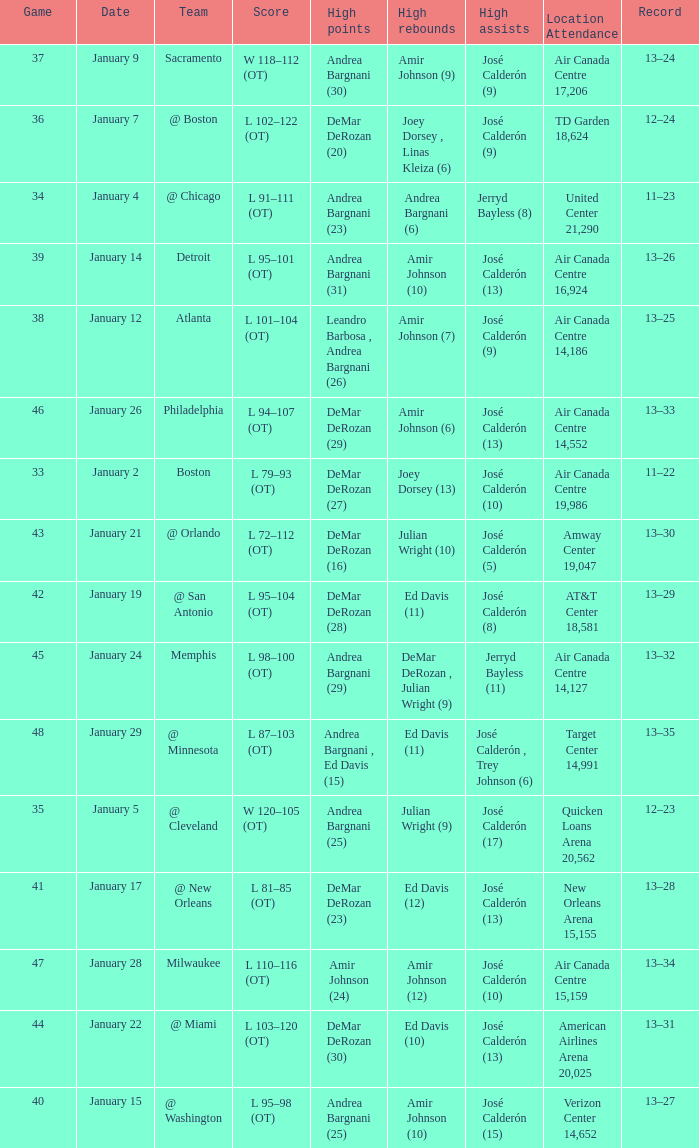Name the number of high rebounds for january 5 1.0. 